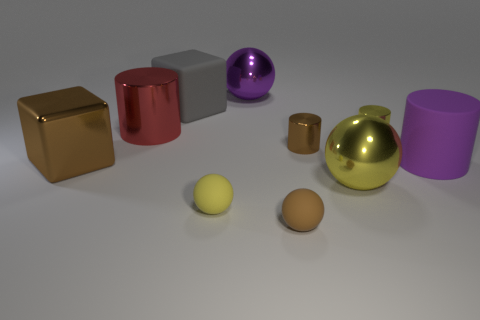Do the small sphere that is to the left of the purple metal object and the big gray block that is to the left of the tiny yellow rubber sphere have the same material?
Give a very brief answer. Yes. What shape is the yellow object that is the same size as the red metal object?
Keep it short and to the point. Sphere. Is there a blue rubber object of the same shape as the brown matte object?
Make the answer very short. No. Is the color of the large cylinder that is in front of the brown metal cylinder the same as the cube that is behind the brown shiny cylinder?
Offer a terse response. No. Are there any small shiny cylinders left of the big red metal cylinder?
Offer a very short reply. No. There is a object that is behind the tiny brown metal thing and to the right of the tiny brown matte ball; what is its material?
Keep it short and to the point. Metal. Does the cube that is on the left side of the large red cylinder have the same material as the gray cube?
Offer a terse response. No. What is the red cylinder made of?
Provide a short and direct response. Metal. What size is the shiny cylinder that is left of the gray rubber block?
Make the answer very short. Large. Is there anything else that has the same color as the matte block?
Your answer should be very brief. No. 